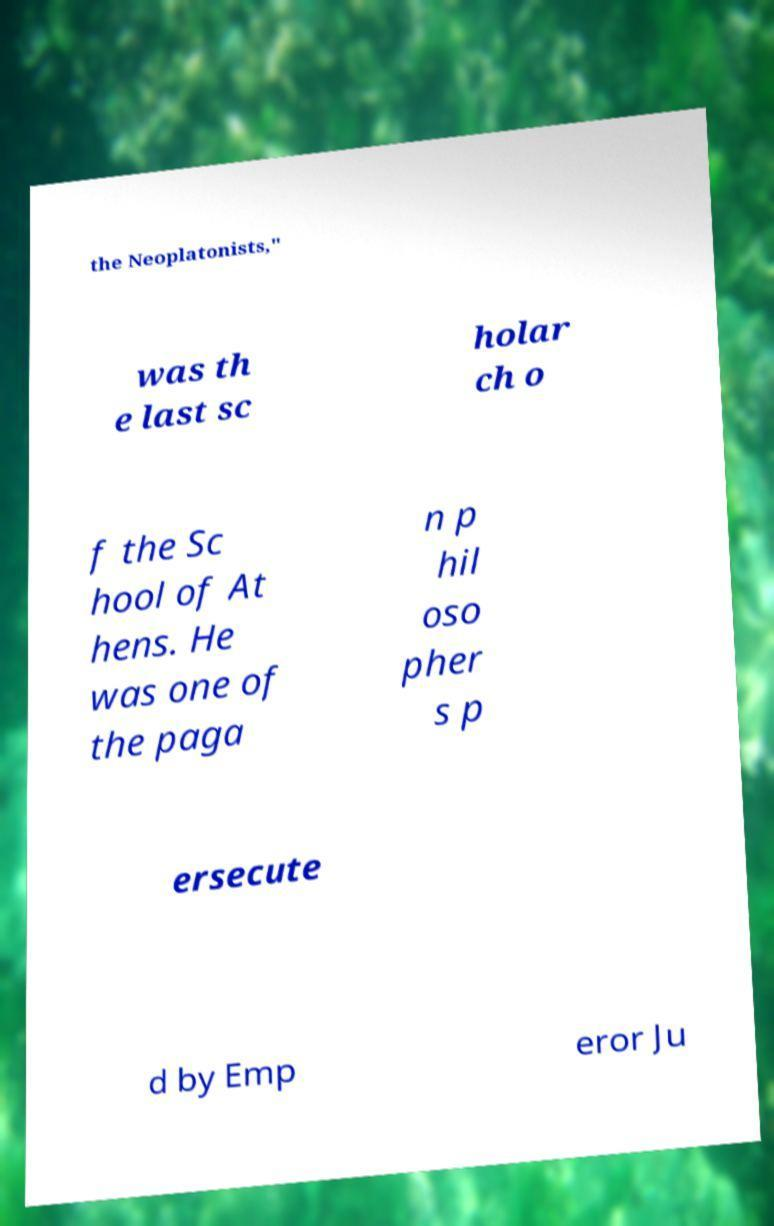Could you extract and type out the text from this image? the Neoplatonists," was th e last sc holar ch o f the Sc hool of At hens. He was one of the paga n p hil oso pher s p ersecute d by Emp eror Ju 